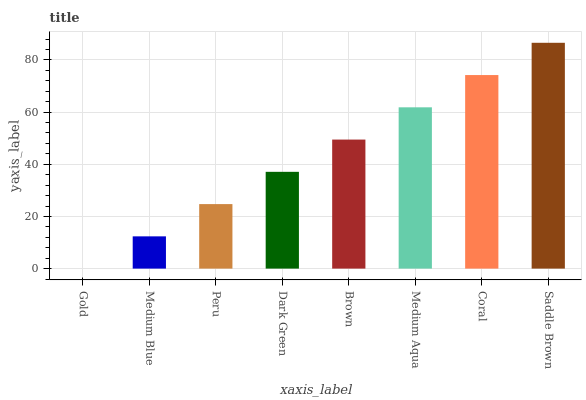Is Gold the minimum?
Answer yes or no. Yes. Is Saddle Brown the maximum?
Answer yes or no. Yes. Is Medium Blue the minimum?
Answer yes or no. No. Is Medium Blue the maximum?
Answer yes or no. No. Is Medium Blue greater than Gold?
Answer yes or no. Yes. Is Gold less than Medium Blue?
Answer yes or no. Yes. Is Gold greater than Medium Blue?
Answer yes or no. No. Is Medium Blue less than Gold?
Answer yes or no. No. Is Brown the high median?
Answer yes or no. Yes. Is Dark Green the low median?
Answer yes or no. Yes. Is Peru the high median?
Answer yes or no. No. Is Peru the low median?
Answer yes or no. No. 